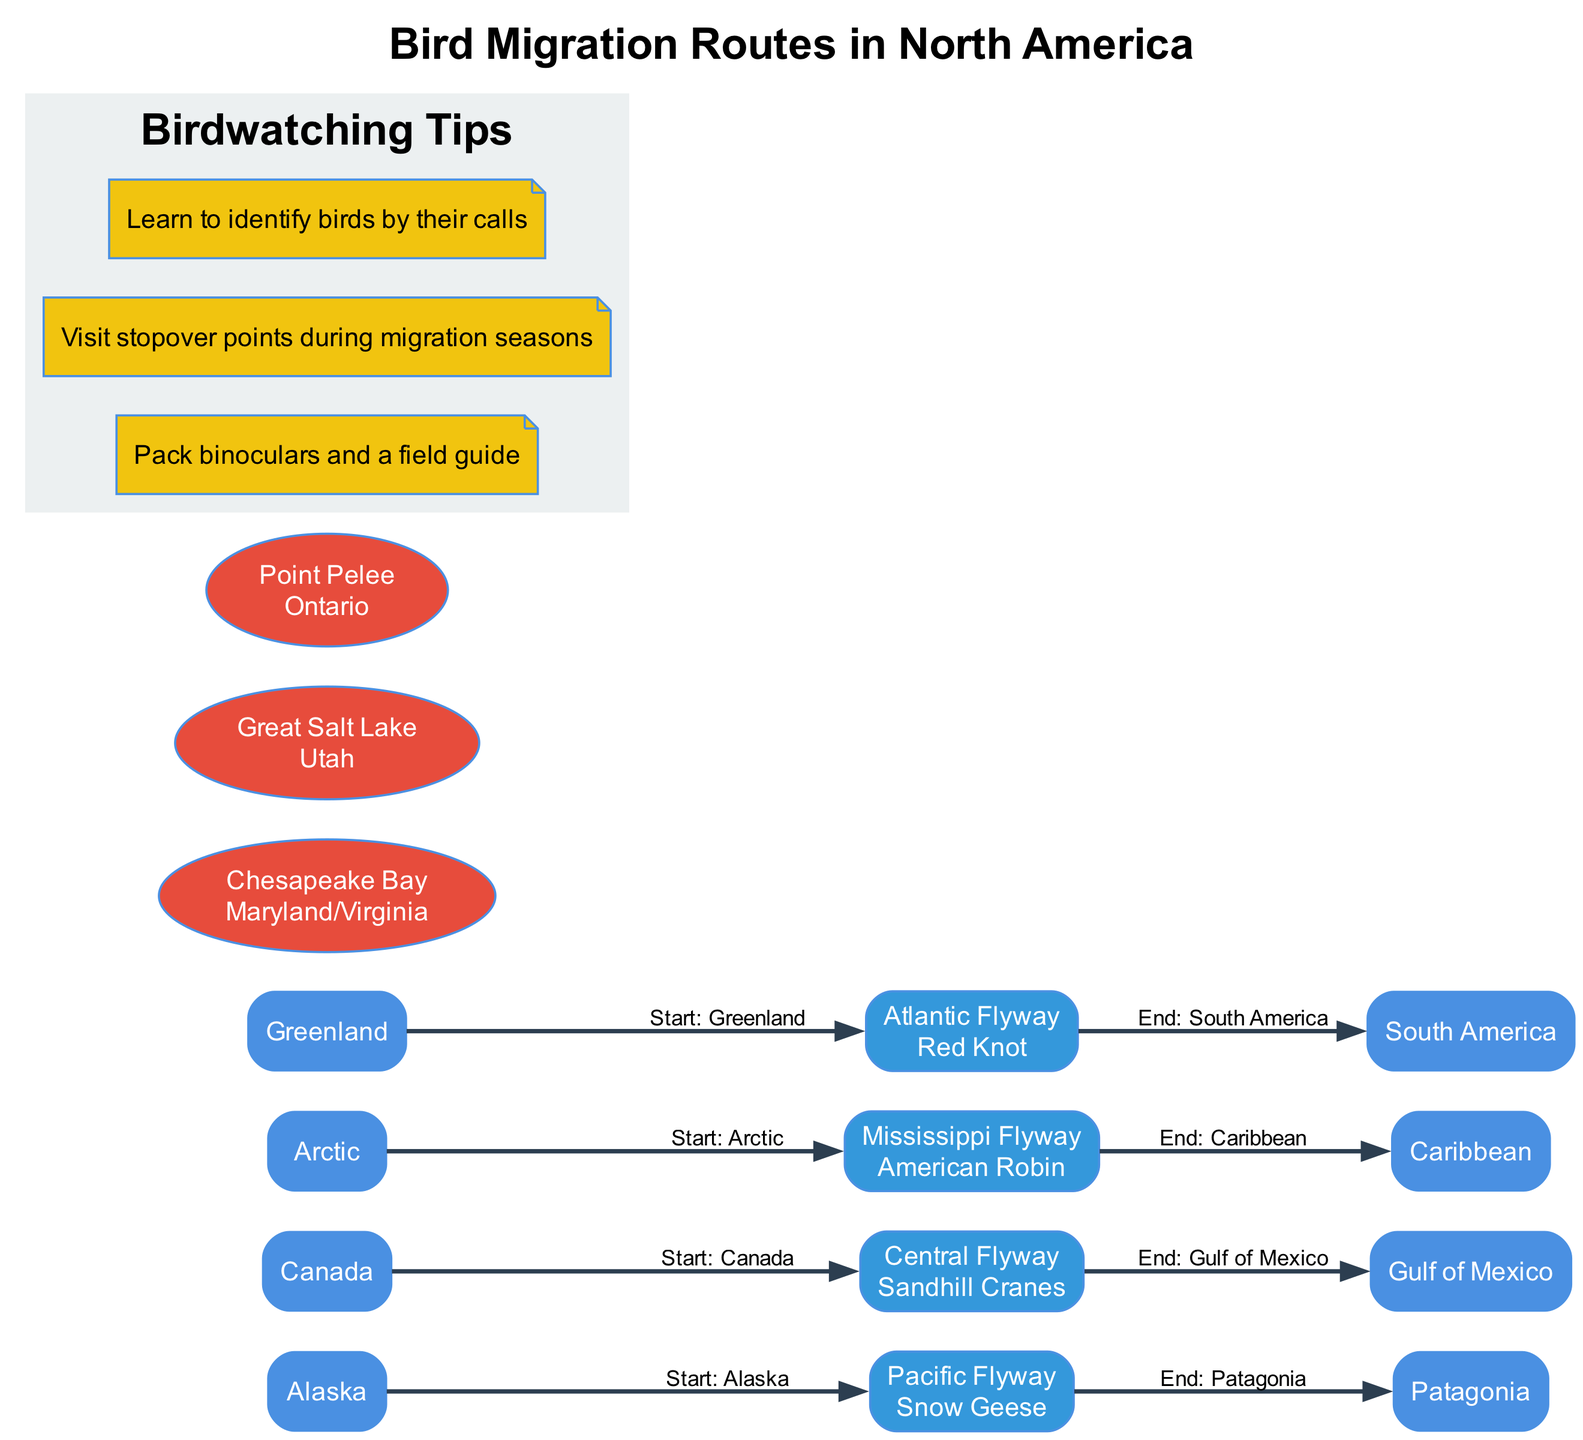What are the starting points of the Pacific Flyway? The diagram shows the starting point of the Pacific Flyway as "Alaska", which is labeled under the respective route node.
Answer: Alaska How many main migration routes are shown in the diagram? By counting the nodes labeled as main migration routes, there are four routes indicated: Pacific Flyway, Central Flyway, Mississippi Flyway, and Atlantic Flyway.
Answer: 4 Which bird species is associated with the Central Flyway? Looking at the Central Flyway node in the diagram, it clearly lists "Sandhill Cranes" as the key species associated with that route.
Answer: Sandhill Cranes What is the significance of Chesapeake Bay as a stopover point? The diagram describes Chesapeake Bay as having "Rich feeding grounds," indicating its importance for migratory birds during their journey.
Answer: Rich feeding grounds Which migration route connects from Canada to the Gulf of Mexico? The Central Flyway node details that it connects the starting point at Canada and ends at the Gulf of Mexico, thus identifying it directly.
Answer: Central Flyway How many important stopover points are listed in the diagram? The diagram presents a total of three important stopover points, which are Chesapeake Bay, Great Salt Lake, and Point Pelee.
Answer: 3 What kind of tips does the diagram offer for birdwatching? Within a subgraph labeled "Birdwatching Tips," the diagram includes several tips, such as packing binoculars, visiting during migration seasons, and learning bird calls.
Answer: Birdwatching tips Which bird species migrates along the Mississippi Flyway? The diagram specifies that the key species migrating along the Mississippi Flyway is the "American Robin," mentioned directly under its route node.
Answer: American Robin What is the end point of the Atlantic Flyway? The Atlantic Flyway is indicated to end at "South America," providing a clear endpoint for this migration route on the diagram.
Answer: South America 